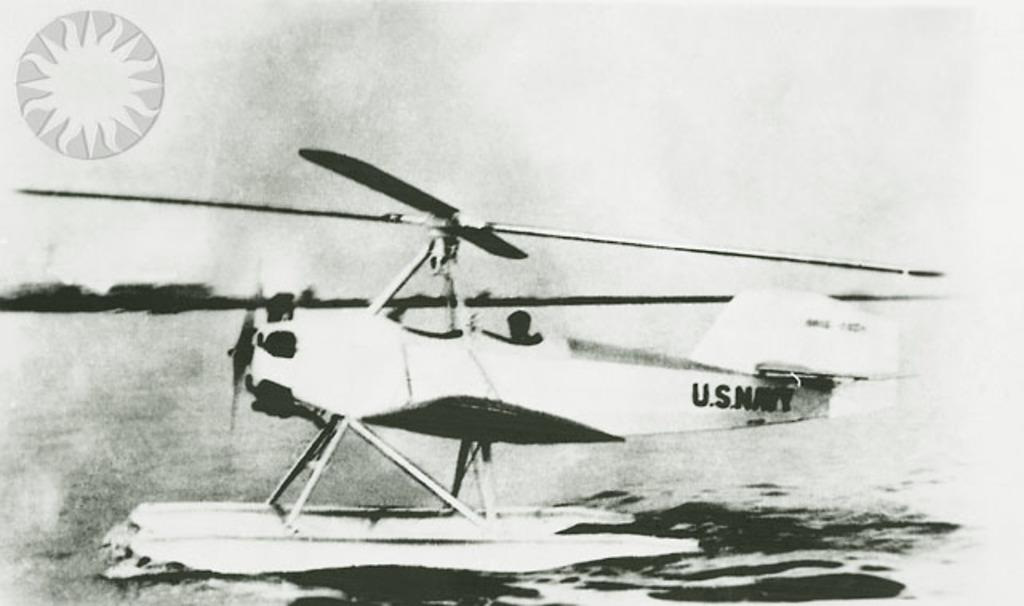<image>
Give a short and clear explanation of the subsequent image. U.S Navy wrote in black on a airplane. 